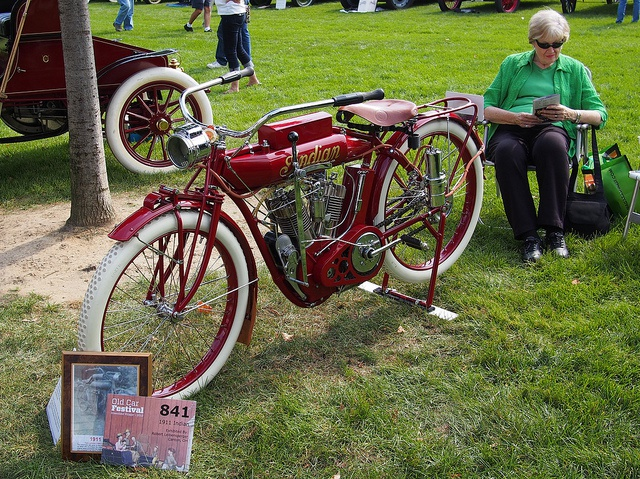Describe the objects in this image and their specific colors. I can see bicycle in black, maroon, darkgray, and gray tones, people in black, green, darkgreen, and gray tones, handbag in black, gray, and darkgreen tones, people in black, lightgray, navy, and gray tones, and chair in black, darkgreen, and olive tones in this image. 